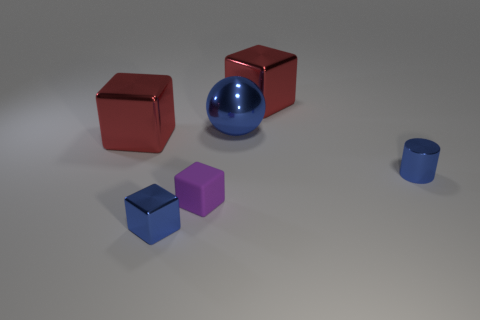Subtract all tiny purple matte cubes. How many cubes are left? 3 Add 2 tiny cylinders. How many objects exist? 8 Subtract all red cylinders. How many red blocks are left? 2 Subtract all purple blocks. How many blocks are left? 3 Subtract 0 cyan spheres. How many objects are left? 6 Subtract all blocks. How many objects are left? 2 Subtract 1 cylinders. How many cylinders are left? 0 Subtract all red cylinders. Subtract all gray spheres. How many cylinders are left? 1 Subtract all small yellow rubber things. Subtract all purple matte cubes. How many objects are left? 5 Add 3 big metallic balls. How many big metallic balls are left? 4 